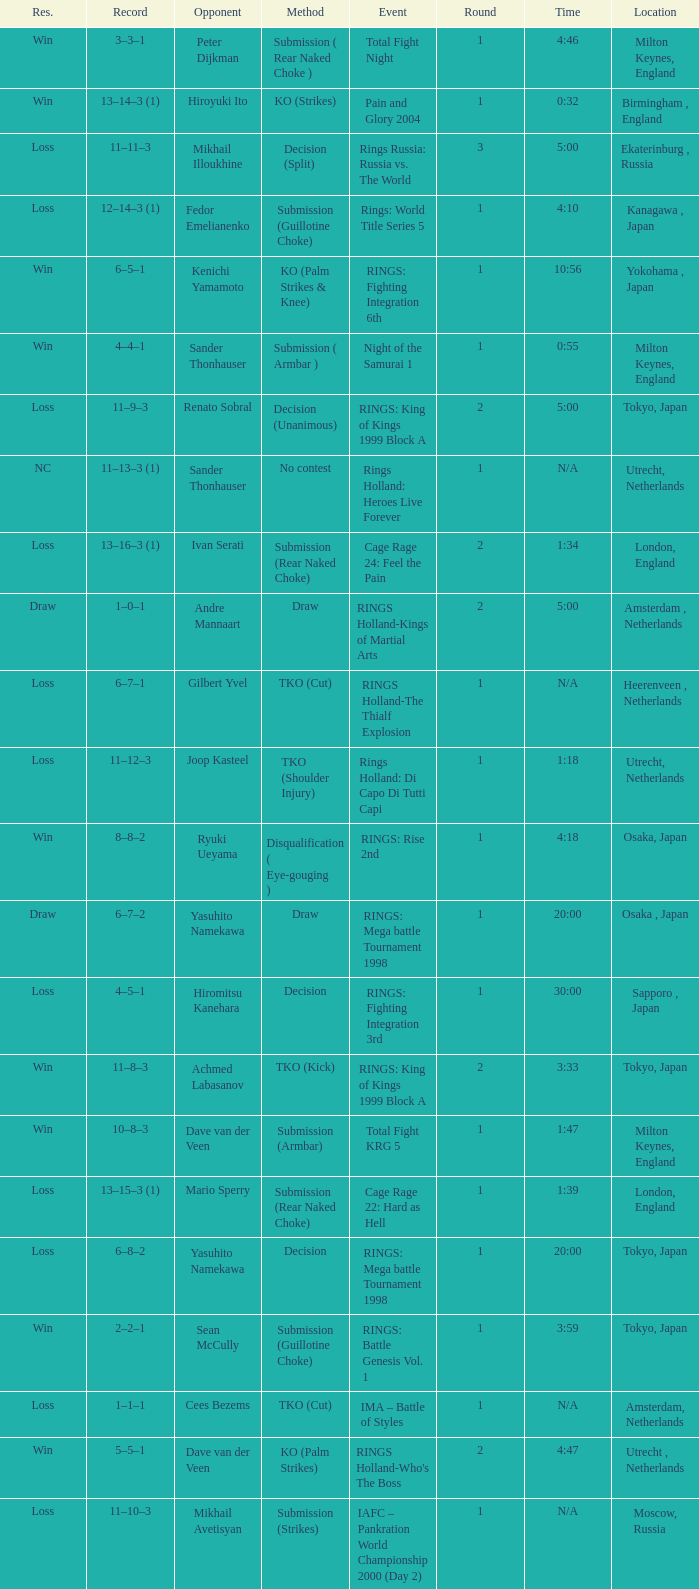Who was the opponent in London, England in a round less than 2? Mario Sperry. 